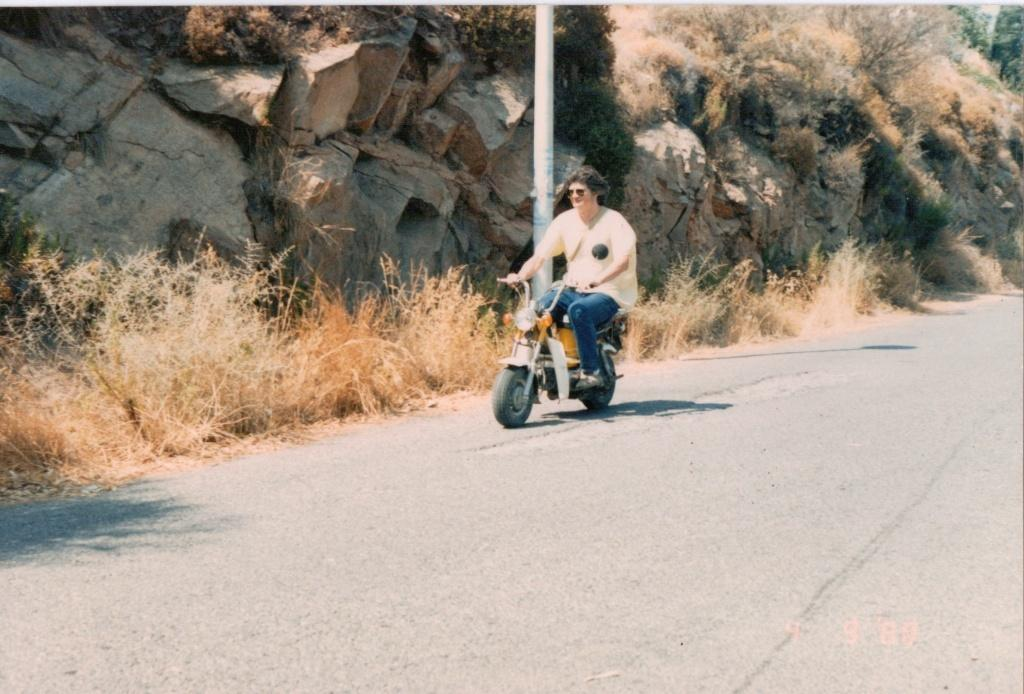Where is the location of the image? The image is outside of the city. What is the weather like in the image? It is a sunny day in the image. What is the man in the image doing? The man is riding a bike on the road. What type of geographical feature can be seen in the background? Rock mountains are visible in the background. What is the condition of the vegetation on the road? Dry grass is present on the road. What else can be seen in the background of the image? There are trees in the background. What type of property does the secretary own in the image? There is no mention of a property or a secretary in the image. 